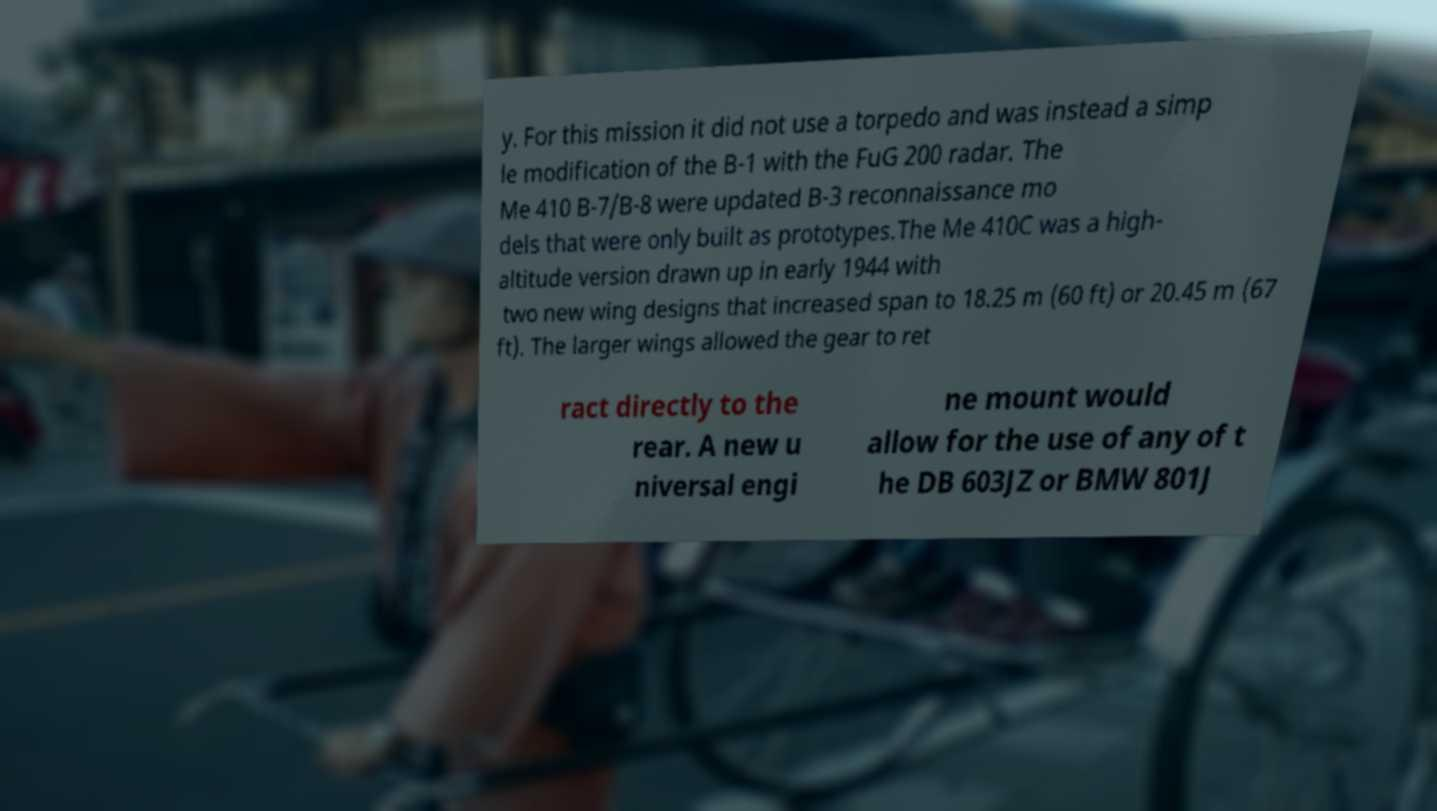For documentation purposes, I need the text within this image transcribed. Could you provide that? y. For this mission it did not use a torpedo and was instead a simp le modification of the B-1 with the FuG 200 radar. The Me 410 B-7/B-8 were updated B-3 reconnaissance mo dels that were only built as prototypes.The Me 410C was a high- altitude version drawn up in early 1944 with two new wing designs that increased span to 18.25 m (60 ft) or 20.45 m (67 ft). The larger wings allowed the gear to ret ract directly to the rear. A new u niversal engi ne mount would allow for the use of any of t he DB 603JZ or BMW 801J 